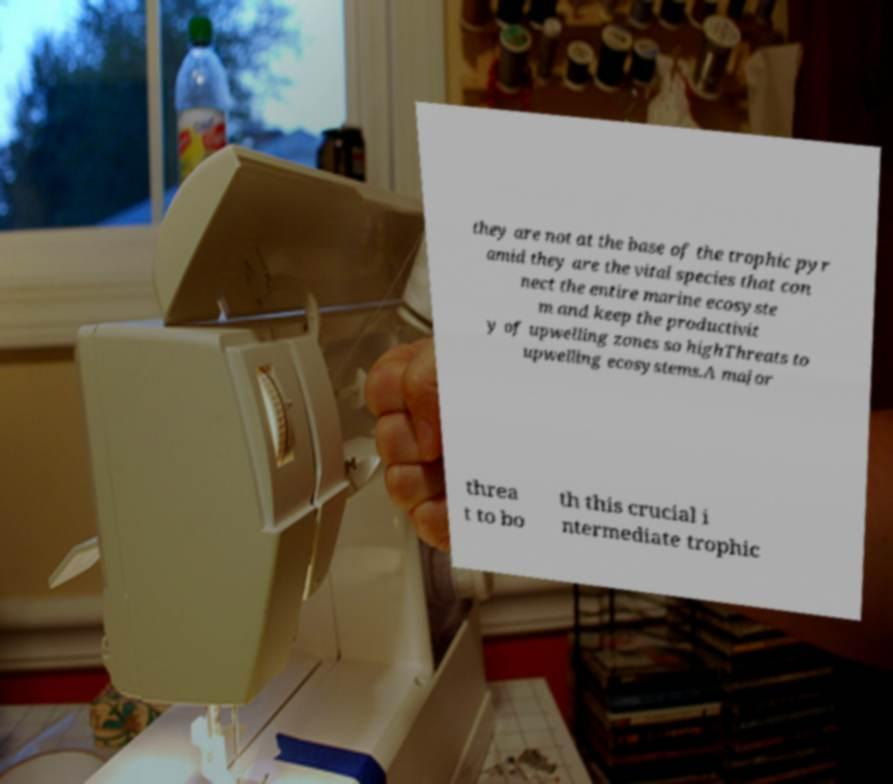Could you assist in decoding the text presented in this image and type it out clearly? they are not at the base of the trophic pyr amid they are the vital species that con nect the entire marine ecosyste m and keep the productivit y of upwelling zones so highThreats to upwelling ecosystems.A major threa t to bo th this crucial i ntermediate trophic 